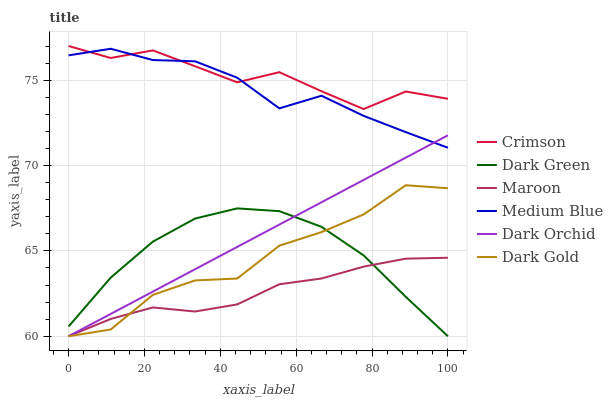Does Maroon have the minimum area under the curve?
Answer yes or no. Yes. Does Crimson have the maximum area under the curve?
Answer yes or no. Yes. Does Medium Blue have the minimum area under the curve?
Answer yes or no. No. Does Medium Blue have the maximum area under the curve?
Answer yes or no. No. Is Dark Orchid the smoothest?
Answer yes or no. Yes. Is Crimson the roughest?
Answer yes or no. Yes. Is Medium Blue the smoothest?
Answer yes or no. No. Is Medium Blue the roughest?
Answer yes or no. No. Does Dark Gold have the lowest value?
Answer yes or no. Yes. Does Medium Blue have the lowest value?
Answer yes or no. No. Does Crimson have the highest value?
Answer yes or no. Yes. Does Medium Blue have the highest value?
Answer yes or no. No. Is Dark Green less than Medium Blue?
Answer yes or no. Yes. Is Medium Blue greater than Maroon?
Answer yes or no. Yes. Does Dark Green intersect Dark Orchid?
Answer yes or no. Yes. Is Dark Green less than Dark Orchid?
Answer yes or no. No. Is Dark Green greater than Dark Orchid?
Answer yes or no. No. Does Dark Green intersect Medium Blue?
Answer yes or no. No. 